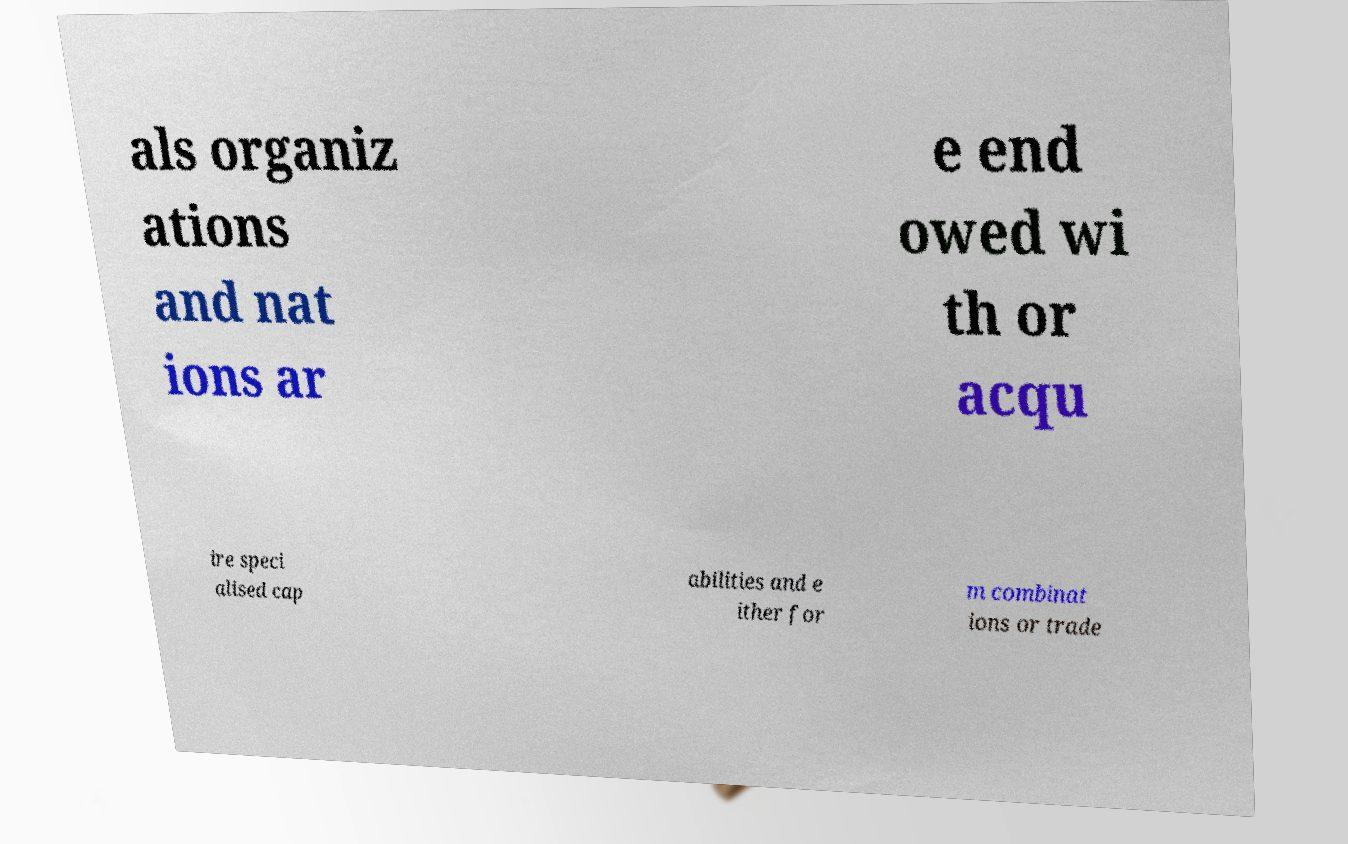Could you assist in decoding the text presented in this image and type it out clearly? als organiz ations and nat ions ar e end owed wi th or acqu ire speci alised cap abilities and e ither for m combinat ions or trade 